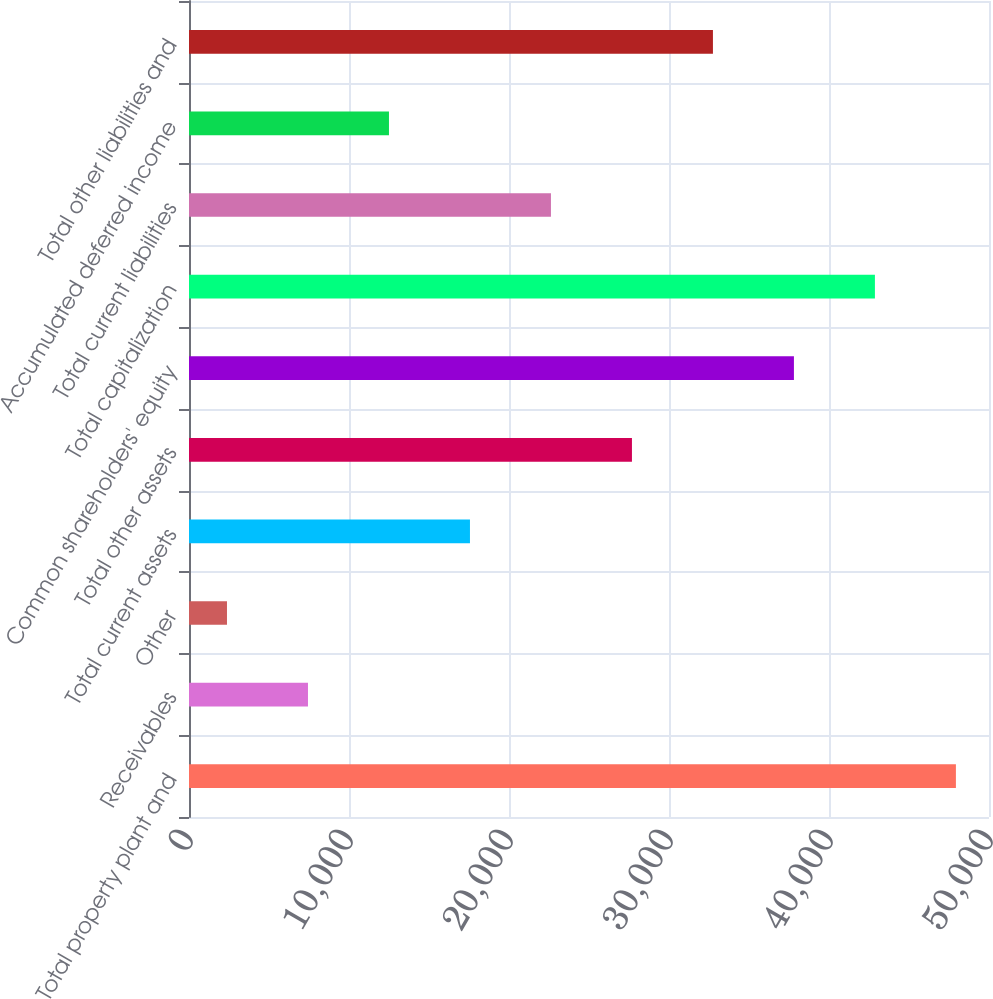<chart> <loc_0><loc_0><loc_500><loc_500><bar_chart><fcel>Total property plant and<fcel>Receivables<fcel>Other<fcel>Total current assets<fcel>Total other assets<fcel>Common shareholders' equity<fcel>Total capitalization<fcel>Total current liabilities<fcel>Accumulated deferred income<fcel>Total other liabilities and<nl><fcel>47932<fcel>7436<fcel>2374<fcel>17560<fcel>27684<fcel>37808<fcel>42870<fcel>22622<fcel>12498<fcel>32746<nl></chart> 